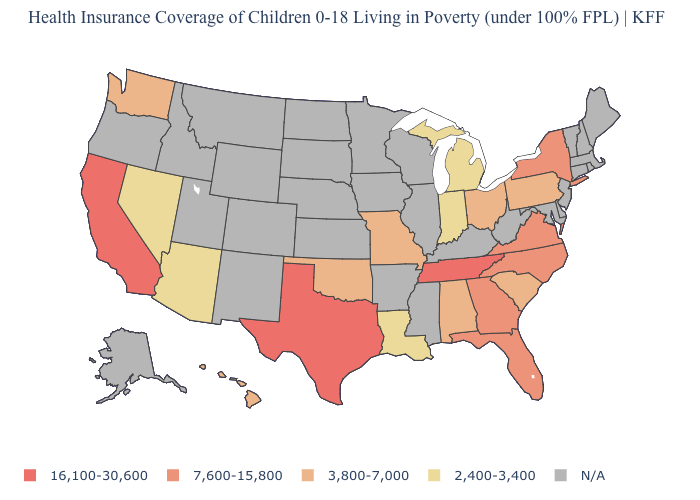What is the lowest value in states that border Mississippi?
Be succinct. 2,400-3,400. Does the first symbol in the legend represent the smallest category?
Give a very brief answer. No. What is the value of Wyoming?
Concise answer only. N/A. What is the value of Montana?
Write a very short answer. N/A. Which states hav the highest value in the West?
Short answer required. California. How many symbols are there in the legend?
Write a very short answer. 5. Among the states that border Indiana , which have the lowest value?
Quick response, please. Michigan. What is the highest value in the West ?
Be succinct. 16,100-30,600. Among the states that border Vermont , which have the lowest value?
Short answer required. New York. What is the highest value in the USA?
Short answer required. 16,100-30,600. What is the value of California?
Short answer required. 16,100-30,600. What is the value of Missouri?
Quick response, please. 3,800-7,000. Does Arizona have the highest value in the West?
Keep it brief. No. What is the highest value in states that border Florida?
Keep it brief. 7,600-15,800. 